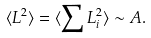<formula> <loc_0><loc_0><loc_500><loc_500>\langle L ^ { 2 } \rangle = \langle \sum L _ { i } ^ { 2 } \rangle \sim A .</formula> 